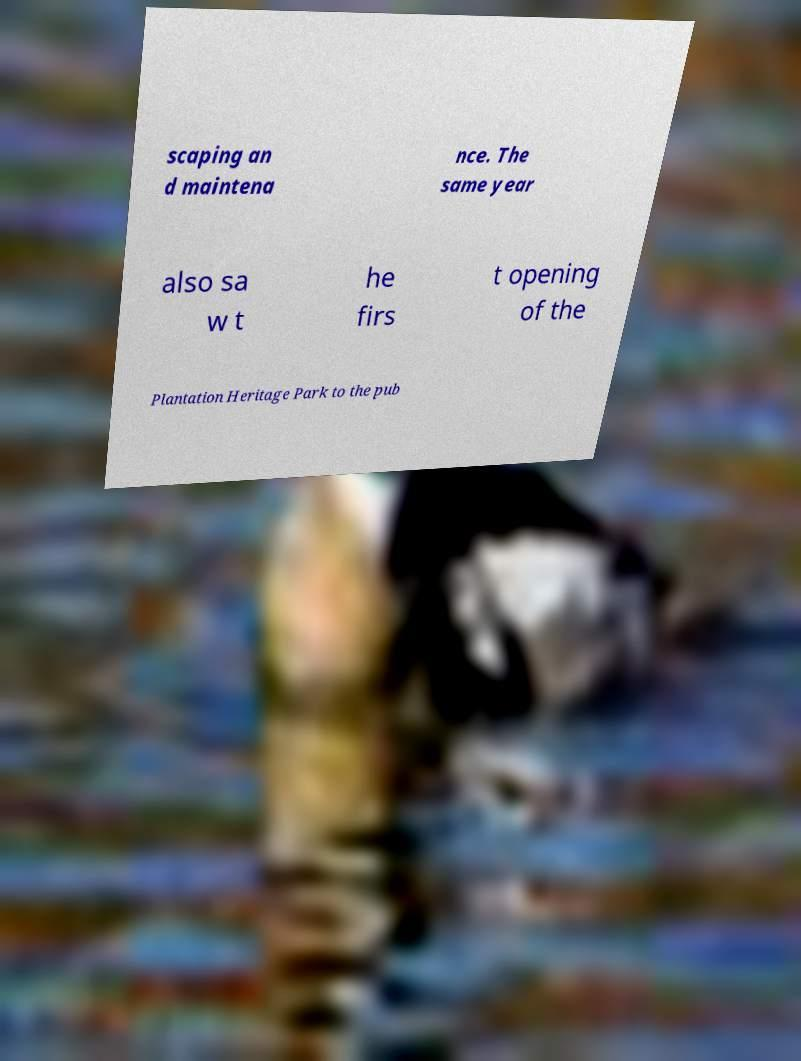Can you read and provide the text displayed in the image?This photo seems to have some interesting text. Can you extract and type it out for me? scaping an d maintena nce. The same year also sa w t he firs t opening of the Plantation Heritage Park to the pub 